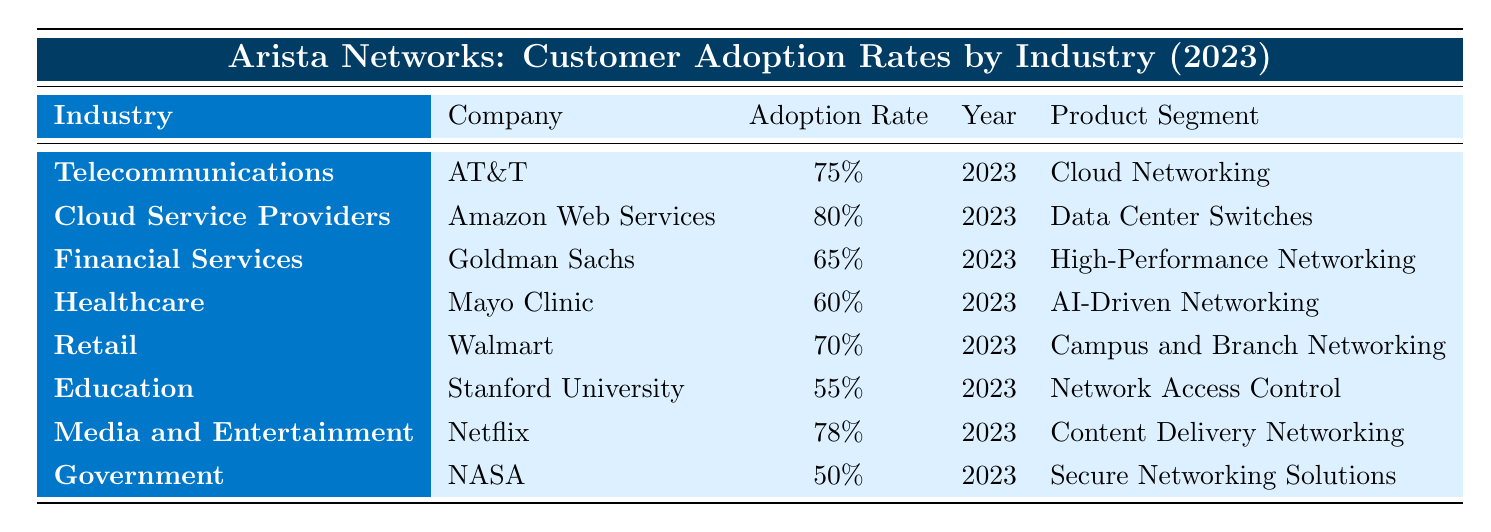What is the adoption rate of AT&T in the telecommunications industry? According to the table, the adoption rate for AT&T is listed under the telecommunications industry and is stated as 75%.
Answer: 75% Which company has the highest adoption rate for Arista Networks products? By reviewing the adoption rates in the table, Amazon Web Services has the highest rate at 80%.
Answer: Amazon Web Services What is the adoption rate for Walmart in the retail sector? The table shows that Walmart is listed under the retail sector with an adoption rate of 70%.
Answer: 70% Which product segment is adopted by Goldman Sachs? The table specifies that Goldman Sachs has adopted the High-Performance Networking product segment.
Answer: High-Performance Networking Is the adoption rate for NASA in the government sector more than 50%? The table indicates that NASA's adoption rate is 50%, which means it is not more than 50%.
Answer: No What is the average adoption rate across all companies listed in the table? To compute the average, we add all the adoption rates (75% + 80% + 65% + 60% + 70% + 55% + 78% + 50% =  615%) and divide by the number of companies (8). The average is 615% / 8 = 76.875%.
Answer: 76.875% Which two industries have adoption rates above 70%? Looking at the table, the industries with adoption rates above 70% are Cloud Service Providers (80%) and Media and Entertainment (78%).
Answer: Cloud Service Providers, Media and Entertainment What is the difference in adoption rates between the healthcare sector and the financial services sector? The adoption rate for healthcare (Mayo Clinic) is 60%, and for financial services (Goldman Sachs), it is 65%. The difference is calculated as 65% - 60% = 5%.
Answer: 5% Which company has a lower adoption rate, Mayo Clinic or Stanford University? Comparing the adoption rates, Mayo Clinic has an adoption rate of 60%, and Stanford University has 55%. Since 55% is lower than 60%, Stanford University has the lower rate.
Answer: Stanford University If you combine the adoption rates of telecommunications and retail, what is the total? The telecommunications sector (AT&T) has an adoption rate of 75%, and the retail sector (Walmart) has 70%. Adding both gives 75% + 70% = 145%.
Answer: 145% 